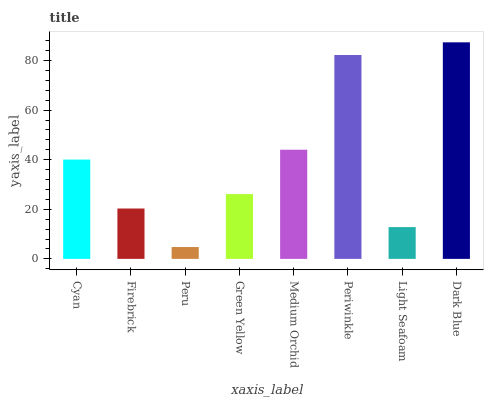Is Firebrick the minimum?
Answer yes or no. No. Is Firebrick the maximum?
Answer yes or no. No. Is Cyan greater than Firebrick?
Answer yes or no. Yes. Is Firebrick less than Cyan?
Answer yes or no. Yes. Is Firebrick greater than Cyan?
Answer yes or no. No. Is Cyan less than Firebrick?
Answer yes or no. No. Is Cyan the high median?
Answer yes or no. Yes. Is Green Yellow the low median?
Answer yes or no. Yes. Is Light Seafoam the high median?
Answer yes or no. No. Is Dark Blue the low median?
Answer yes or no. No. 